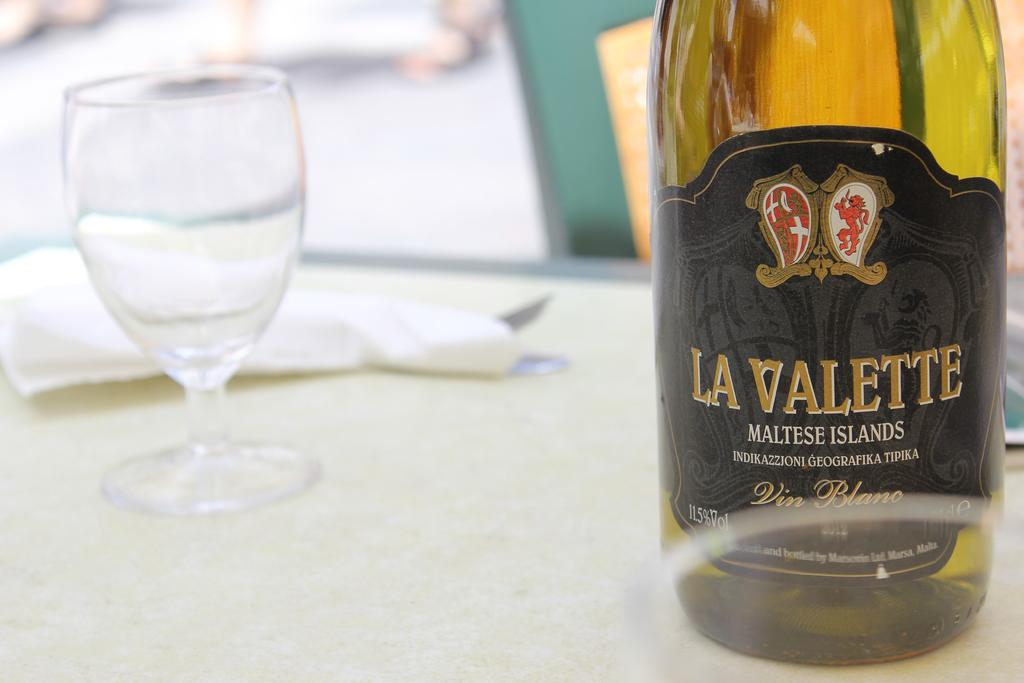What is on the table in the image? There is a glass and a bottle on the table in the image. Can you describe the glass in more detail? The provided facts do not give any additional details about the glass. What is the bottle on the table used for? The provided facts do not specify the purpose of the bottle. How many sheep are in the flock visible in the image? There is no flock of sheep present in the image; it only features a glass and a bottle on a table. 